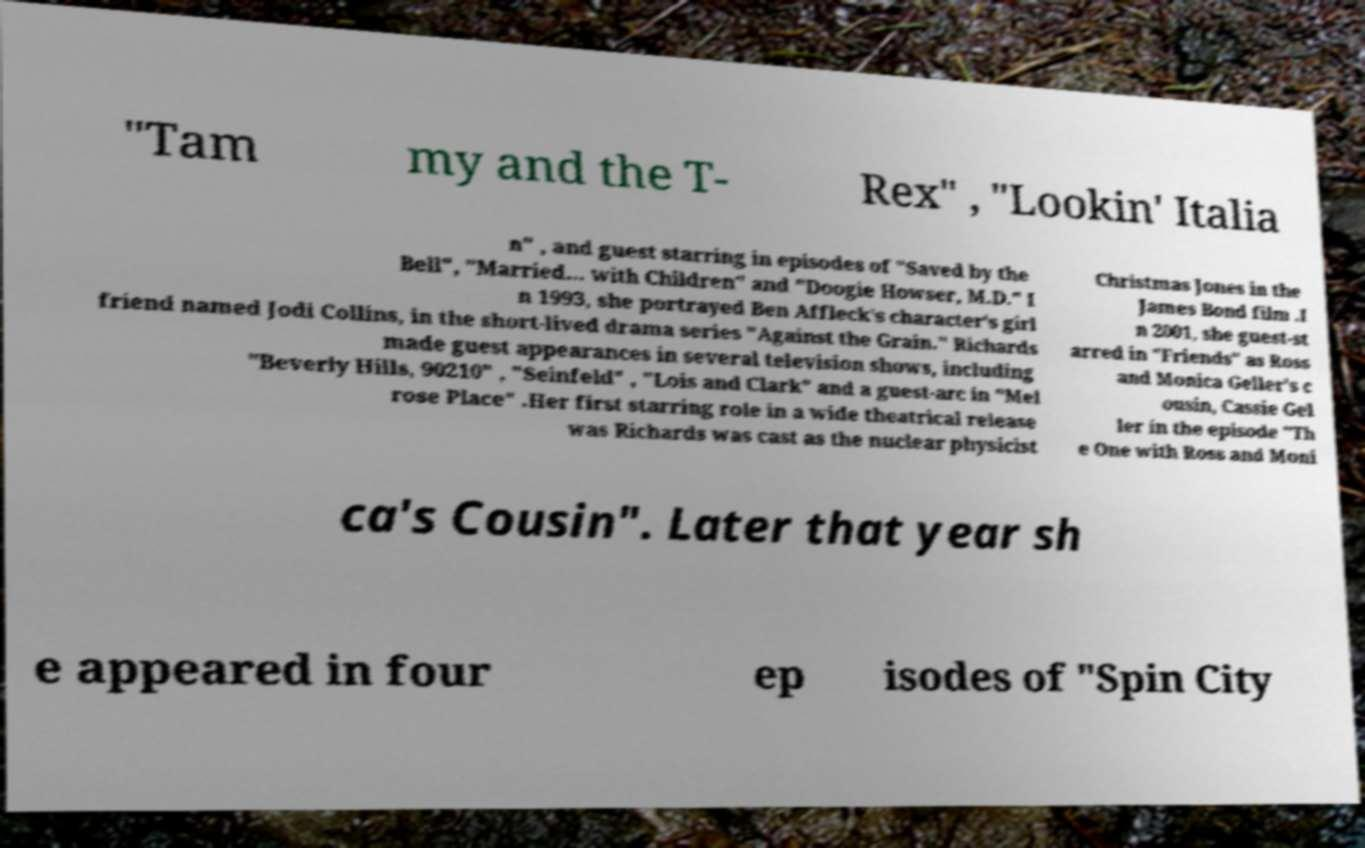For documentation purposes, I need the text within this image transcribed. Could you provide that? "Tam my and the T- Rex" , "Lookin' Italia n" , and guest starring in episodes of "Saved by the Bell", "Married... with Children" and "Doogie Howser, M.D." I n 1993, she portrayed Ben Affleck's character's girl friend named Jodi Collins, in the short-lived drama series "Against the Grain." Richards made guest appearances in several television shows, including "Beverly Hills, 90210" , "Seinfeld" , "Lois and Clark" and a guest-arc in "Mel rose Place" .Her first starring role in a wide theatrical release was Richards was cast as the nuclear physicist Christmas Jones in the James Bond film .I n 2001, she guest-st arred in "Friends" as Ross and Monica Geller's c ousin, Cassie Gel ler in the episode "Th e One with Ross and Moni ca's Cousin". Later that year sh e appeared in four ep isodes of "Spin City 